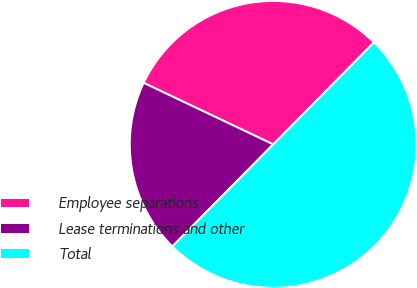Convert chart to OTSL. <chart><loc_0><loc_0><loc_500><loc_500><pie_chart><fcel>Employee separations<fcel>Lease terminations and other<fcel>Total<nl><fcel>30.35%<fcel>19.65%<fcel>50.0%<nl></chart> 